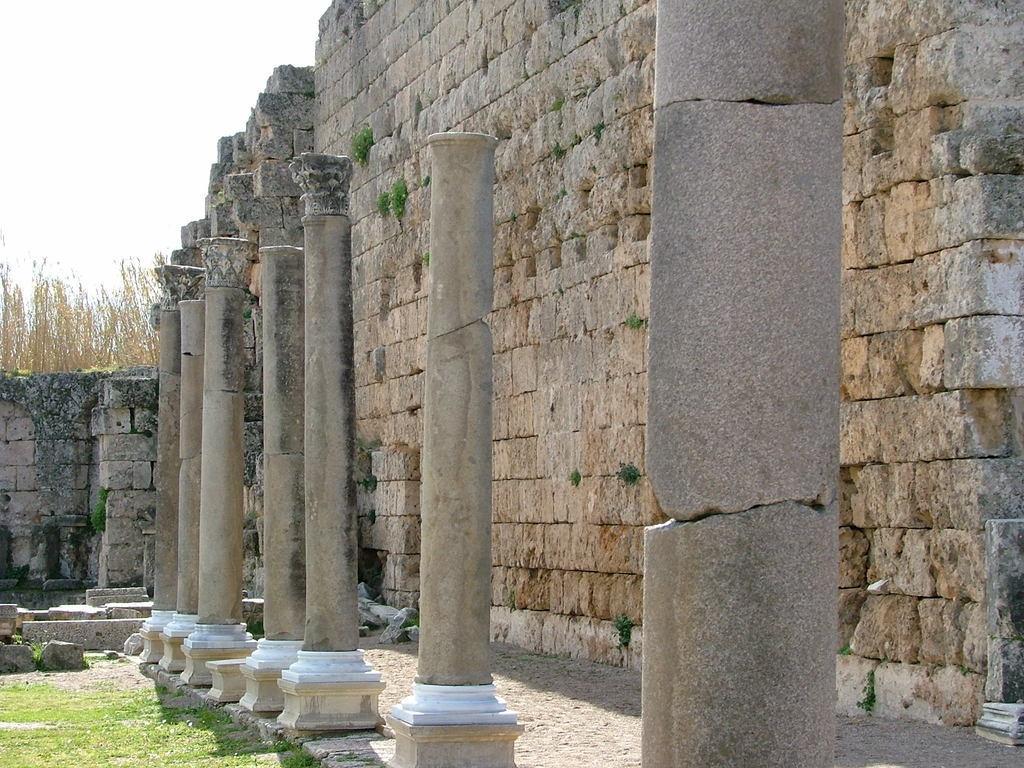Describe this image in one or two sentences. In this image we can see the column pillars, wall, trees, grass and also the stones. We can also see the sky. 